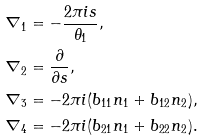<formula> <loc_0><loc_0><loc_500><loc_500>\nabla _ { 1 } & = - \frac { 2 \pi i s } { \theta _ { 1 } } , \\ \nabla _ { 2 } & = \frac { \partial } { \partial s } , \\ \nabla _ { 3 } & = - 2 \pi i ( b _ { 1 1 } n _ { 1 } + b _ { 1 2 } n _ { 2 } ) , \\ \nabla _ { 4 } & = - 2 \pi i ( b _ { 2 1 } n _ { 1 } + b _ { 2 2 } n _ { 2 } ) .</formula> 